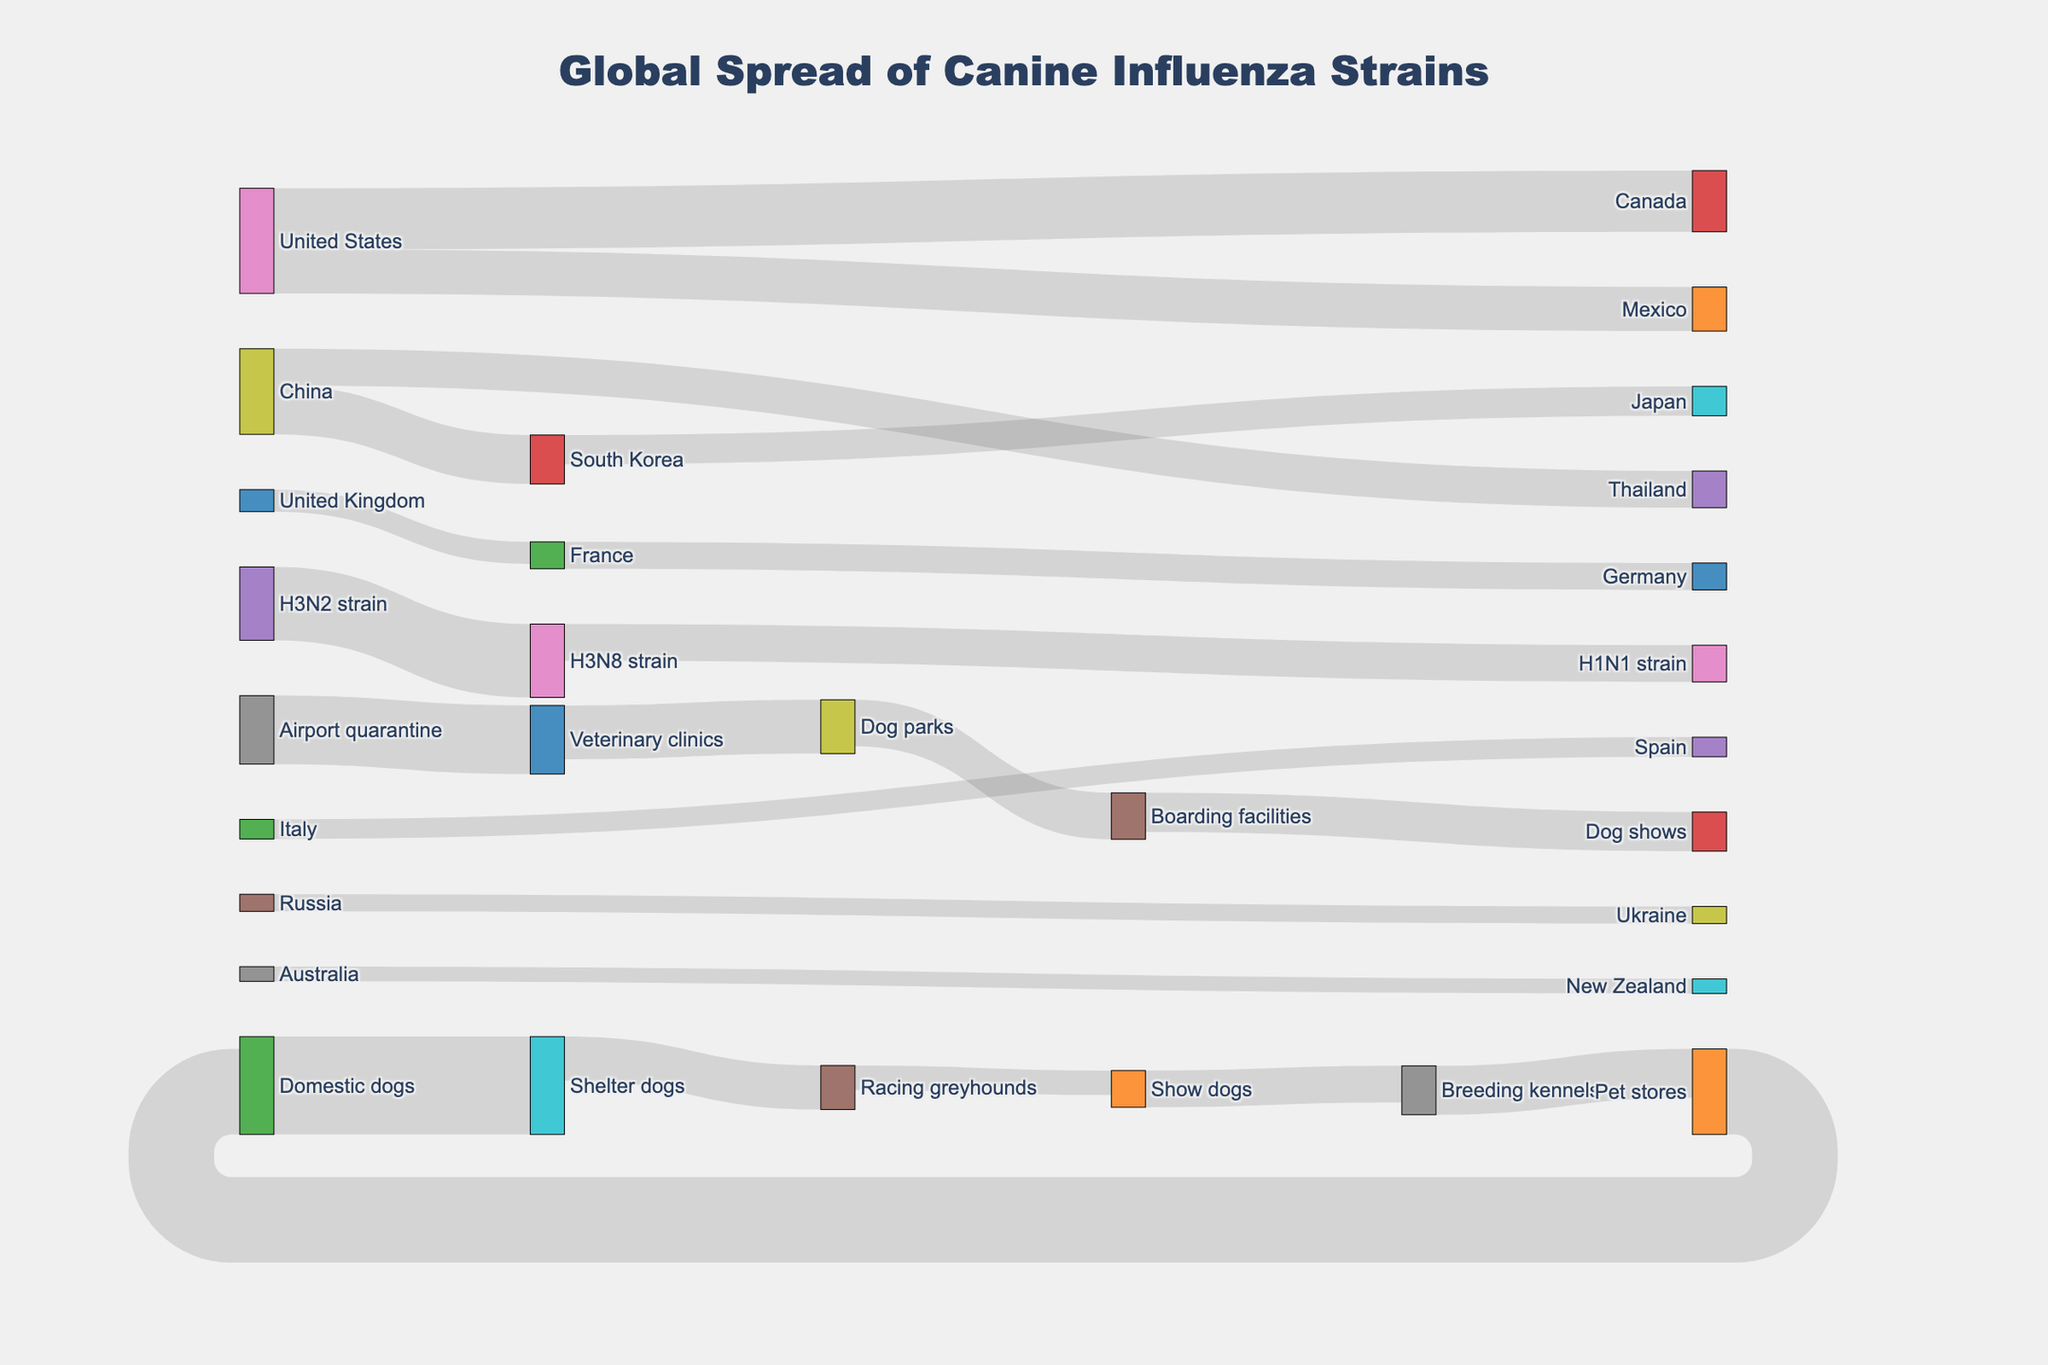what is the main title of the figure? The main title is at the top of the figure, which provides an overview of what the diagram represents. By reading the title, we understand that the Sankey diagram shows the "Global Spread of Canine Influenza Strains".
Answer: Global Spread of Canine Influenza Strains How many countries are involved in the transmission routes shown in the diagram? To find the number of countries, we need to count the unique country names that appear as either a source or target in the figure. By checking the nodes' labels including United States, Canada, Mexico, South Korea, Japan, China, Thailand, United Kingdom, France, Germany, Italy, Spain, Russia, Ukraine, Australia, and New Zealand, we find there are 15 countries.
Answer: 15 Which dog population sees the largest transfer from another population according to the figure? By observing the thickness of the links, the largest transfer is from Domestic dogs to Shelter dogs, as represented by the value number associated with the link, which is 400. Thus, Domestic dogs to Shelter dogs has the largest transfer.
Answer: Shelter dogs How does the transmission of H3N2 strain compare to that of H3N8 strain in terms of dog population? We need to compare the values associated with the transmission of H3N2 strain and H3N8 strain. H3N2 strain transfers to H3N8 strain with a value of 300, while H3N8 strain transfers to H1N1 strain with a value of 150. Thus, H3N8 strain has lower transmission compared to H3N2 strain.
Answer: More for H3N2 What is the total number of transfers involving canine influenza strains? Total the values associated with all strain-related transmissions. These include H3N2 to H3N8 (300) and H3N8 to H1N1 (150), summing to 300 + 150 = 450.
Answer: 450 Which country does China transfer canine influenza to, and what is the combined transfer amount? China transfers to South Korea and Thailand. By adding the transfer values to these countries, the combined amount is 200 (South Korea) + 150 (Thailand) = 350.
Answer: South Korea and Thailand, 350 Can you find the sequence of dog populations starting from Domestic dogs to Pet stores in the figure? We follow the path from Domestic dogs to Pet stores by tracing the flow of arrows. The sequence is Domestic dogs -> Shelter dogs -> Racing greyhounds -> Show dogs -> Breeding kennels -> Pet stores.
Answer: Domestic dogs → Shelter dogs → Racing greyhounds → Show dogs → Breeding kennels → Pet stores Which country receives the least amount of canine influenza from any other country in this figure and what is the value? By comparing the values of the links directed toward different countries, the smallest value is 60 which is Australia's transfer to New Zealand.
Answer: New Zealand, 60 From which sources does the Veterinary clinics node receive transfers? Veterinary clinics receive transfers from Airport quarantine with a value of 280.
Answer: Airport quarantine 